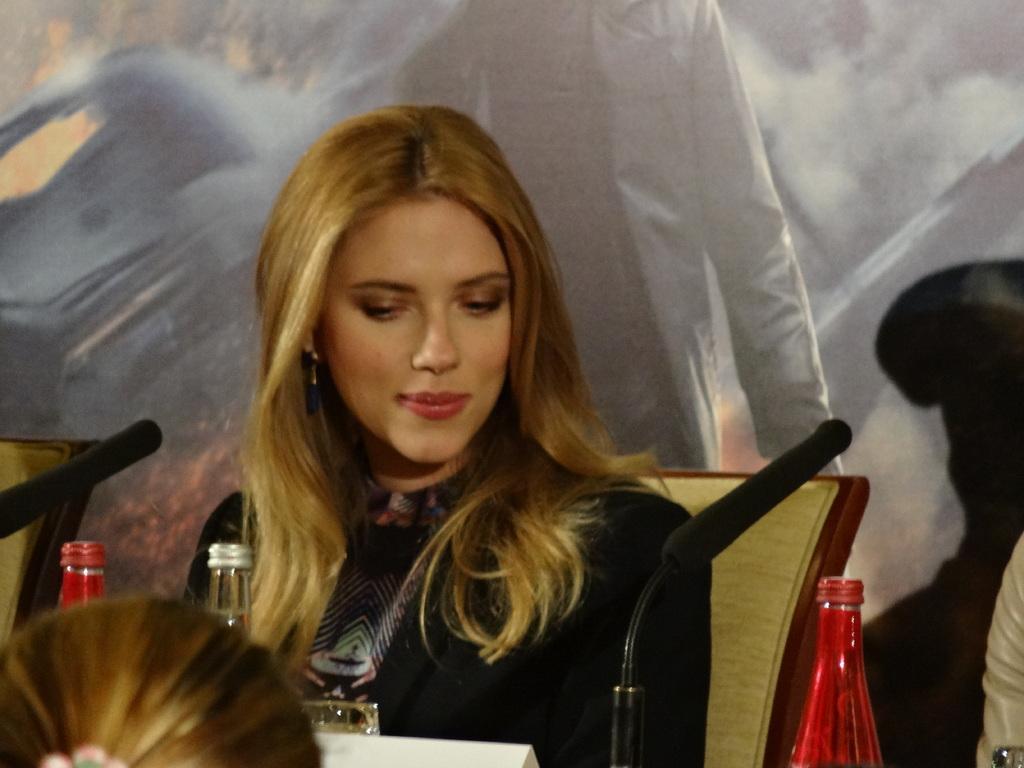Please provide a concise description of this image. In this image we can see a women who is wearing a black dress and she is sitting on the chair. In-front of her there is a table on that we can see a glass and two bottles and a mic. On the bottom right corner we can see a person's hand. On the bottom left corner there is a woman's head. on the background there is a poster which shows a person who is wearing a jacket. 